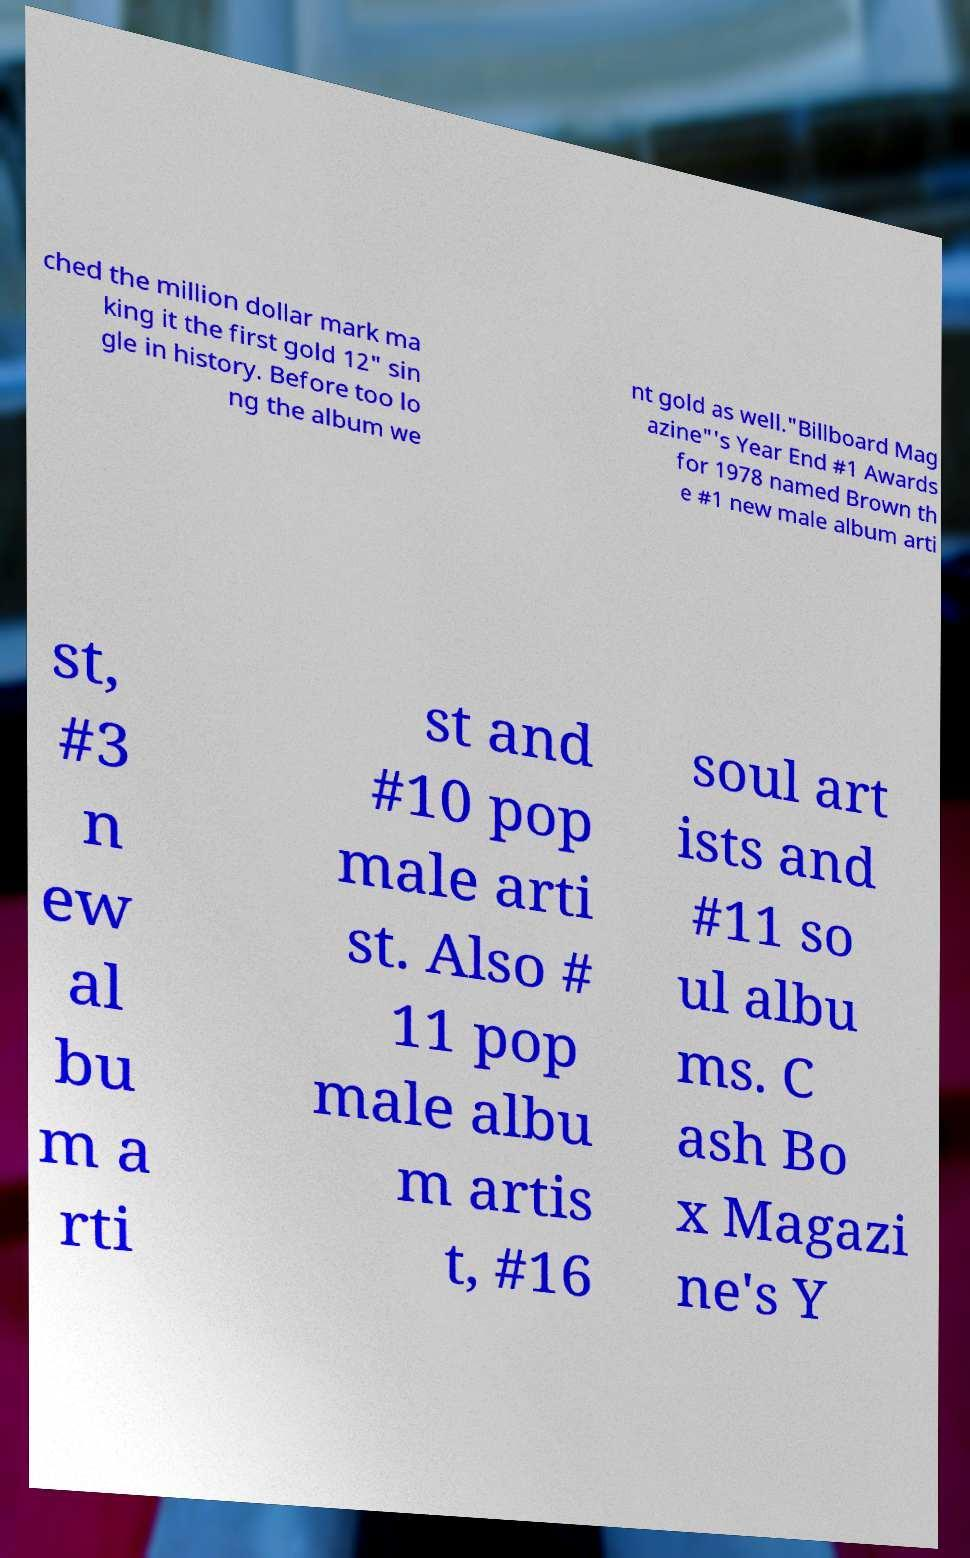Could you extract and type out the text from this image? ched the million dollar mark ma king it the first gold 12" sin gle in history. Before too lo ng the album we nt gold as well."Billboard Mag azine"'s Year End #1 Awards for 1978 named Brown th e #1 new male album arti st, #3 n ew al bu m a rti st and #10 pop male arti st. Also # 11 pop male albu m artis t, #16 soul art ists and #11 so ul albu ms. C ash Bo x Magazi ne's Y 